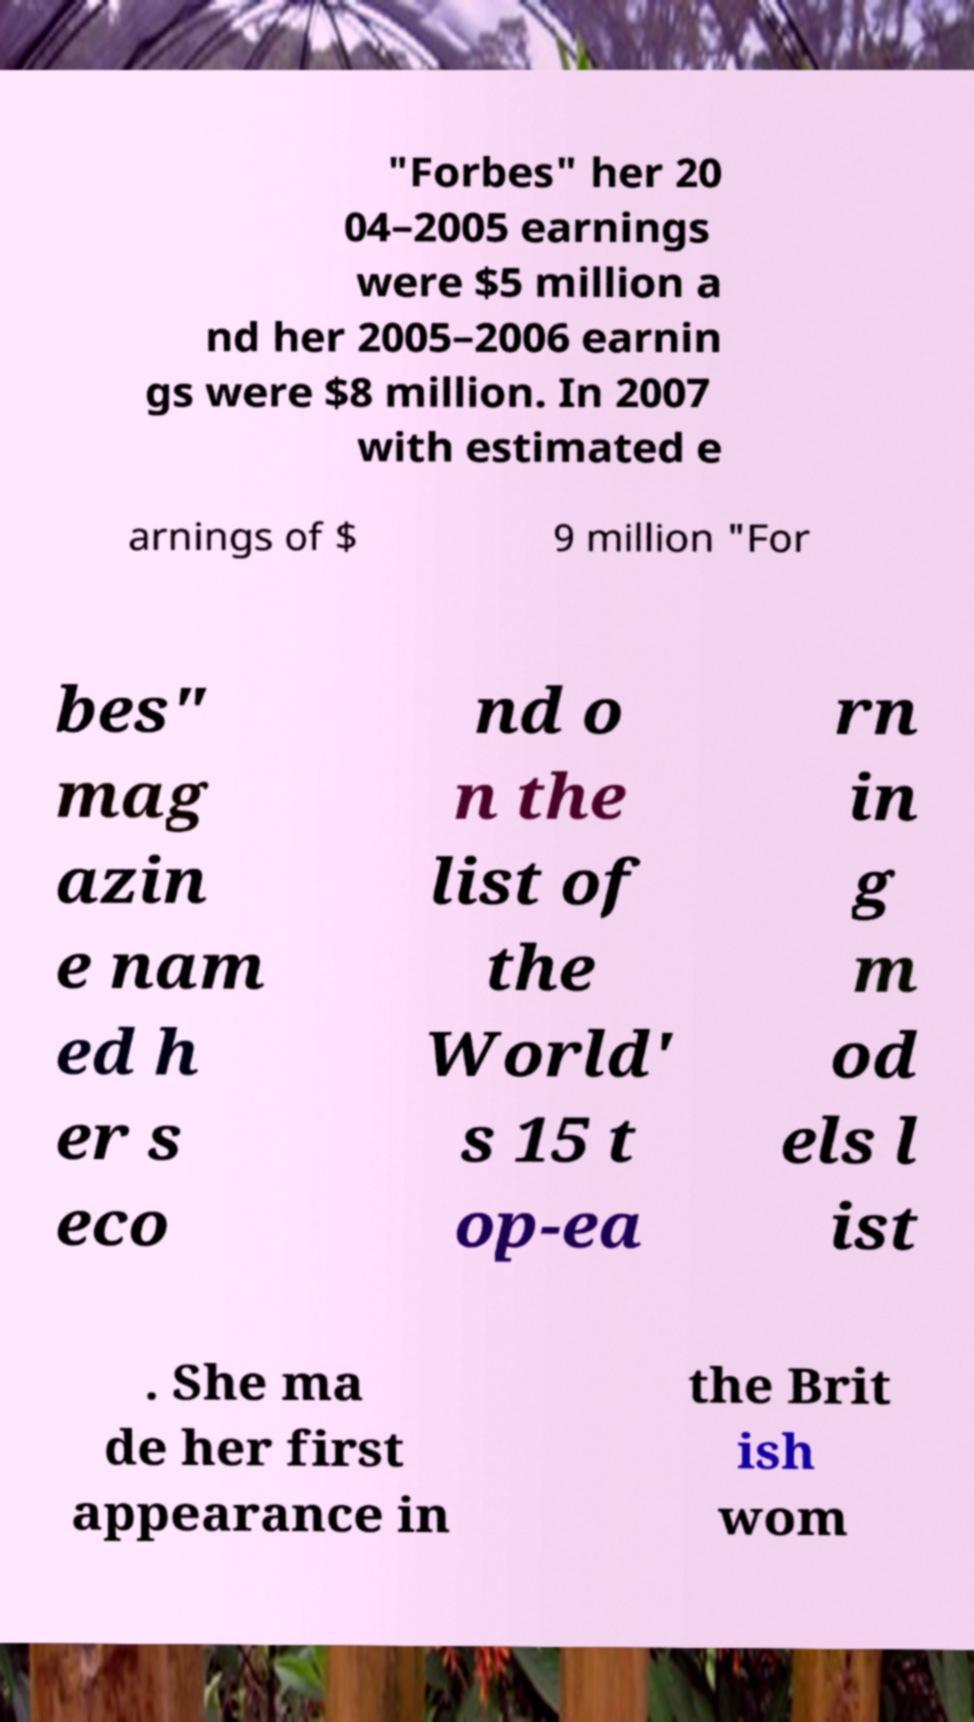For documentation purposes, I need the text within this image transcribed. Could you provide that? "Forbes" her 20 04–2005 earnings were $5 million a nd her 2005–2006 earnin gs were $8 million. In 2007 with estimated e arnings of $ 9 million "For bes" mag azin e nam ed h er s eco nd o n the list of the World' s 15 t op-ea rn in g m od els l ist . She ma de her first appearance in the Brit ish wom 